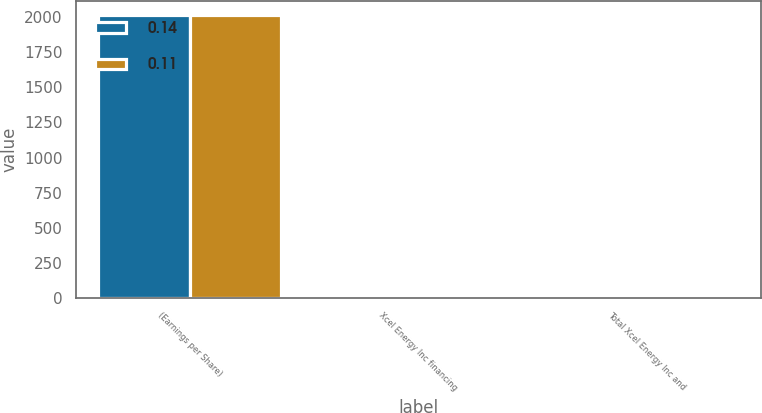Convert chart. <chart><loc_0><loc_0><loc_500><loc_500><stacked_bar_chart><ecel><fcel>(Earnings per Share)<fcel>Xcel Energy Inc financing<fcel>Total Xcel Energy Inc and<nl><fcel>0.14<fcel>2015<fcel>0.11<fcel>0.11<nl><fcel>0.11<fcel>2013<fcel>0.13<fcel>0.14<nl></chart> 